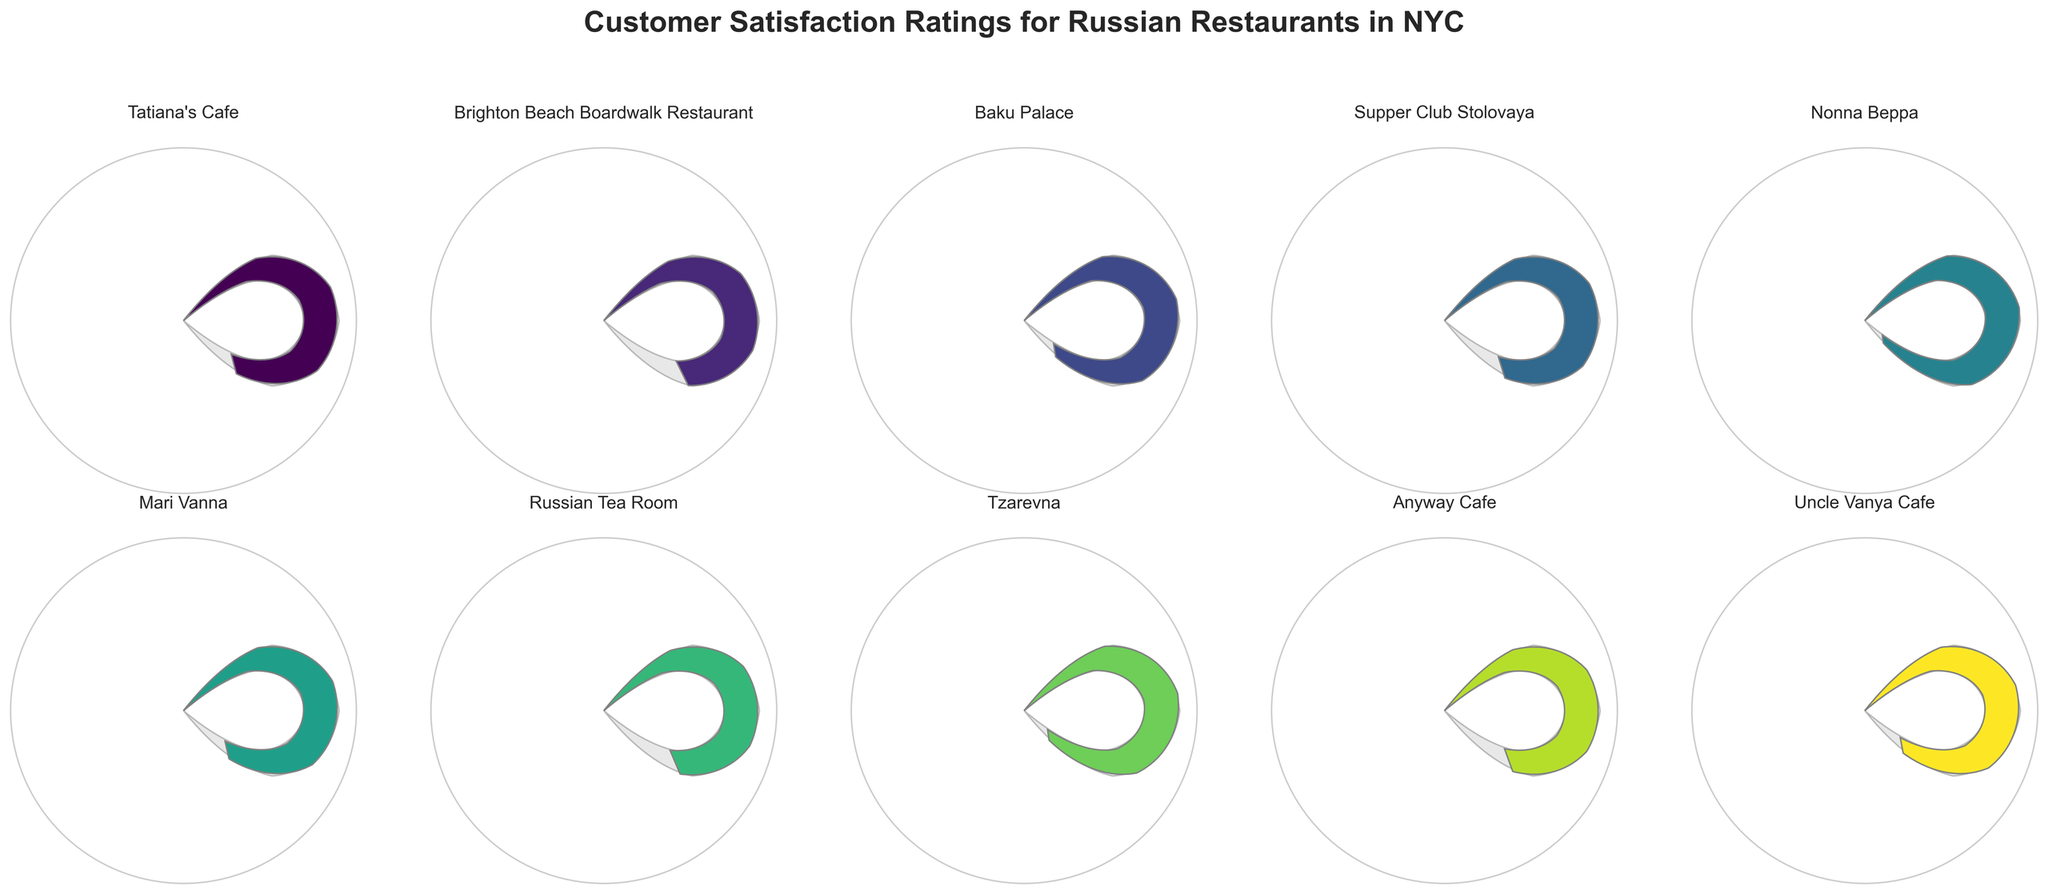What is the title of the chart? The title of the chart is displayed at the top of the figure in a larger, bold font. It summarizes the main topic or dataset being visualized.
Answer: Customer Satisfaction Ratings for Russian Restaurants in NYC How many restaurants are shown in the chart? Each subplot represents a different restaurant, and there are 2 rows with 5 columns, making 10 subplots.
Answer: 10 Which restaurant has the highest satisfaction rating? Locate the subplot with the largest angle wedge overlap, indicating the highest rating. Nonna Beppa displays the highest rating.
Answer: Nonna Beppa What is the satisfaction rating of the Russian Tea Room? The rating is displayed below the wedge in the subplot corresponding to the Russian Tea Room.
Answer: 3.9 Which restaurant has a satisfaction rating of 3.8? Identify the restaurant name in the subplot that has the rating of 3.8 displayed below the gauge's wedge.
Answer: Brighton Beach Boardwalk Restaurant What is the average satisfaction rating of all the restaurants? Sum all satisfaction ratings and divide by the number of restaurants: (4.2 + 3.8 + 4.5 + 4.1 + 4.7 + 4.3 + 3.9 + 4.6 + 4.0 + 4.4) / 10 = 42.5 / 10 = 4.25.
Answer: 4.25 Which restaurant has a higher rating, Mari Vanna or Tzarevna? Compare the ratings displayed in the respective subplots of Mari Vanna and Tzarevna. Tzarevna has a higher rating of 4.6 compared to Mari Vanna's 4.3.
Answer: Tzarevna What is the difference in satisfaction ratings between Tatiana's Cafe and Russian Tea Room? Subtract the satisfaction rating of Russian Tea Room from Tatiana's Cafe: 4.2 - 3.9 = 0.3.
Answer: 0.3 Which restaurant scored exactly 4.0 in the satisfaction rating? Locate the restaurant name associated with the subplot showing a 4.0 rating.
Answer: Anyway Cafe What is the median satisfaction rating of the restaurants? To find the median, sort the ratings and identify the middle value. The sorted ratings are [3.8, 3.9, 4.0, 4.1, 4.2, 4.3, 4.4, 4.5, 4.6, 4.7], and the median is the average of the 5th and 6th values: (4.2 + 4.3) / 2 = 4.25.
Answer: 4.25 